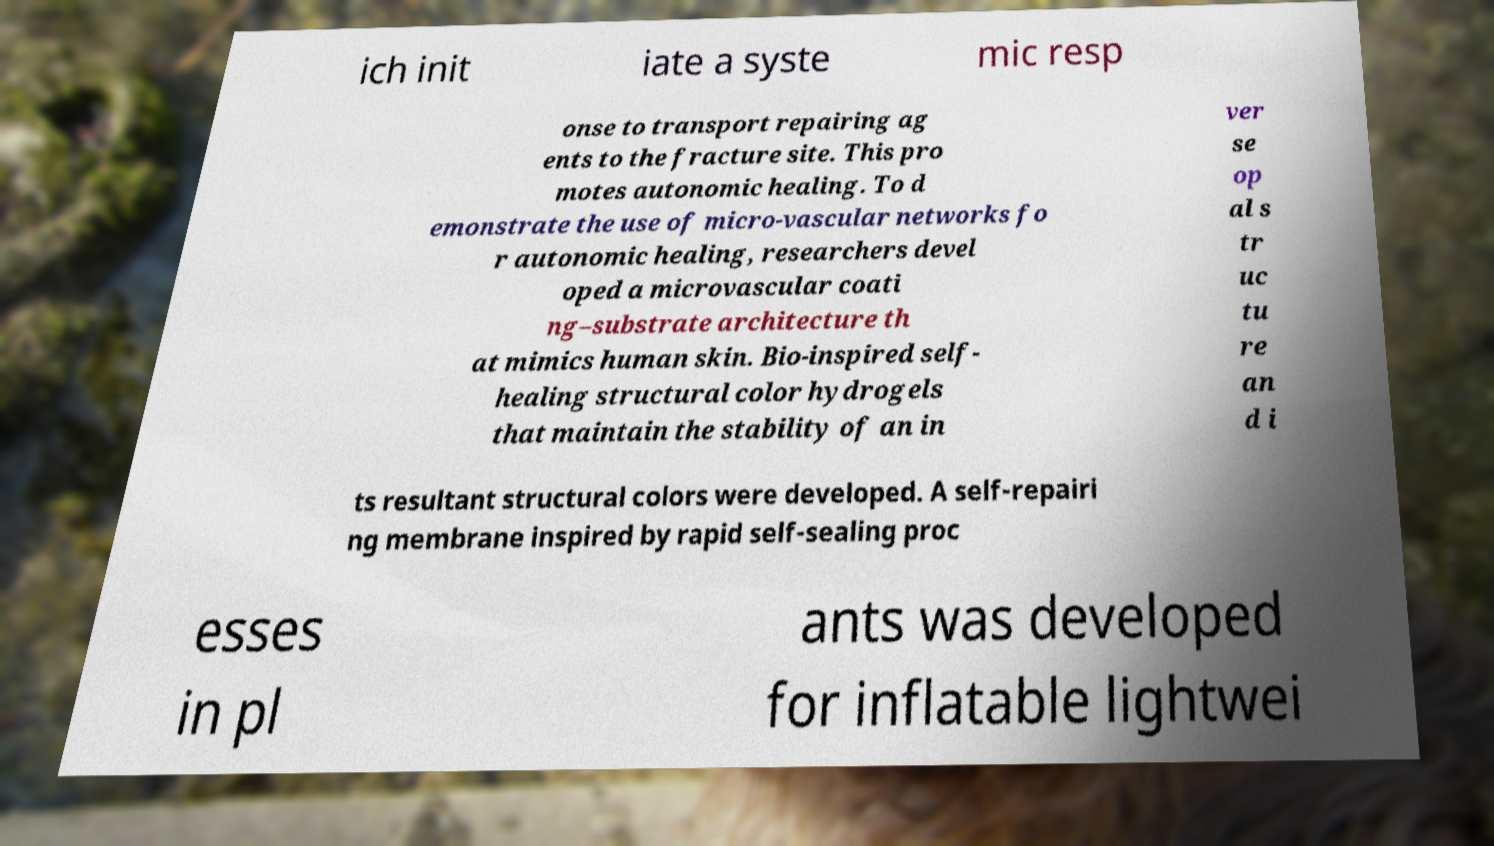Could you assist in decoding the text presented in this image and type it out clearly? ich init iate a syste mic resp onse to transport repairing ag ents to the fracture site. This pro motes autonomic healing. To d emonstrate the use of micro-vascular networks fo r autonomic healing, researchers devel oped a microvascular coati ng–substrate architecture th at mimics human skin. Bio-inspired self- healing structural color hydrogels that maintain the stability of an in ver se op al s tr uc tu re an d i ts resultant structural colors were developed. A self-repairi ng membrane inspired by rapid self-sealing proc esses in pl ants was developed for inflatable lightwei 